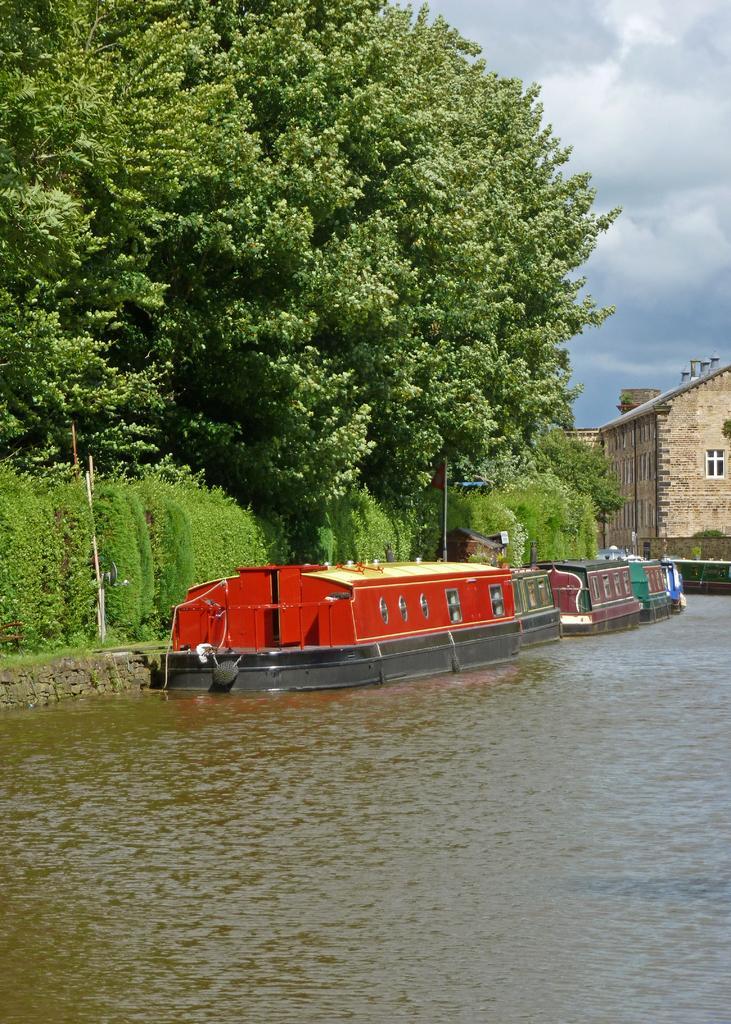In one or two sentences, can you explain what this image depicts? This picture shows trees and couple of boats in the water and we see couple of buildings and a cloudy sky. 